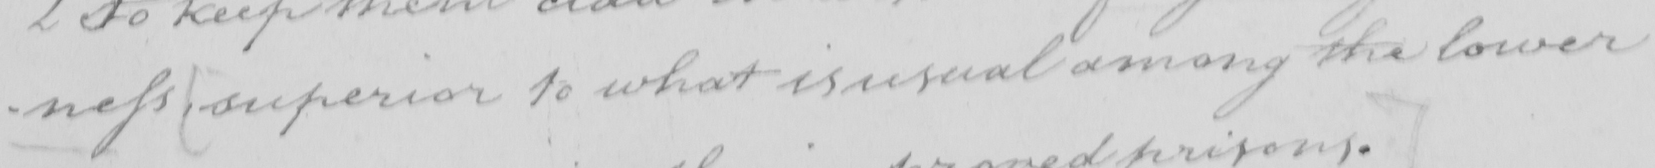Can you tell me what this handwritten text says? -ness  [ superior to what is usual among the lower 